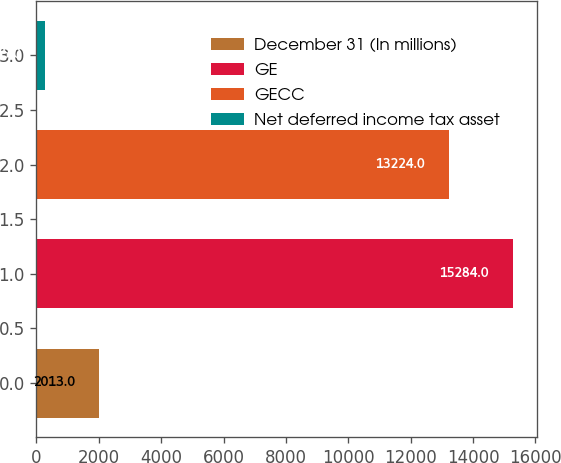Convert chart. <chart><loc_0><loc_0><loc_500><loc_500><bar_chart><fcel>December 31 (In millions)<fcel>GE<fcel>GECC<fcel>Net deferred income tax asset<nl><fcel>2013<fcel>15284<fcel>13224<fcel>275<nl></chart> 